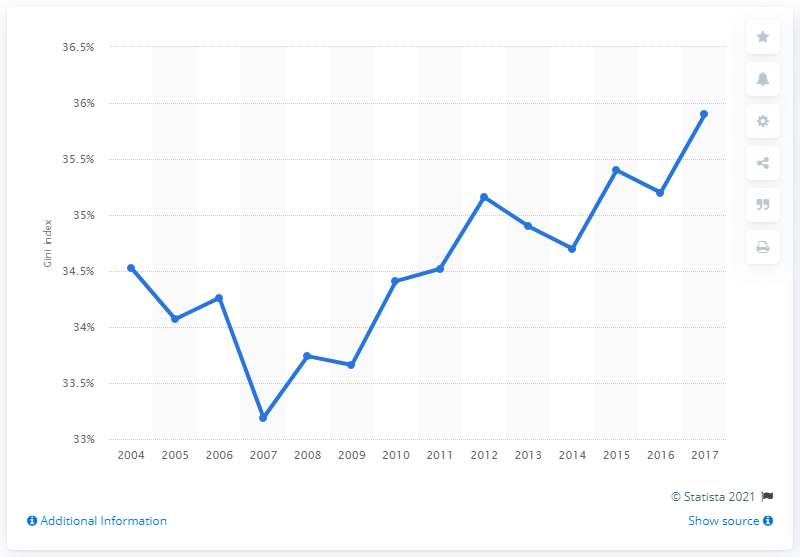Mention a couple of crucial points in this snapshot. The Gini coefficient in Italy in 2017 was 35.9, indicating a moderate level of income inequality. 